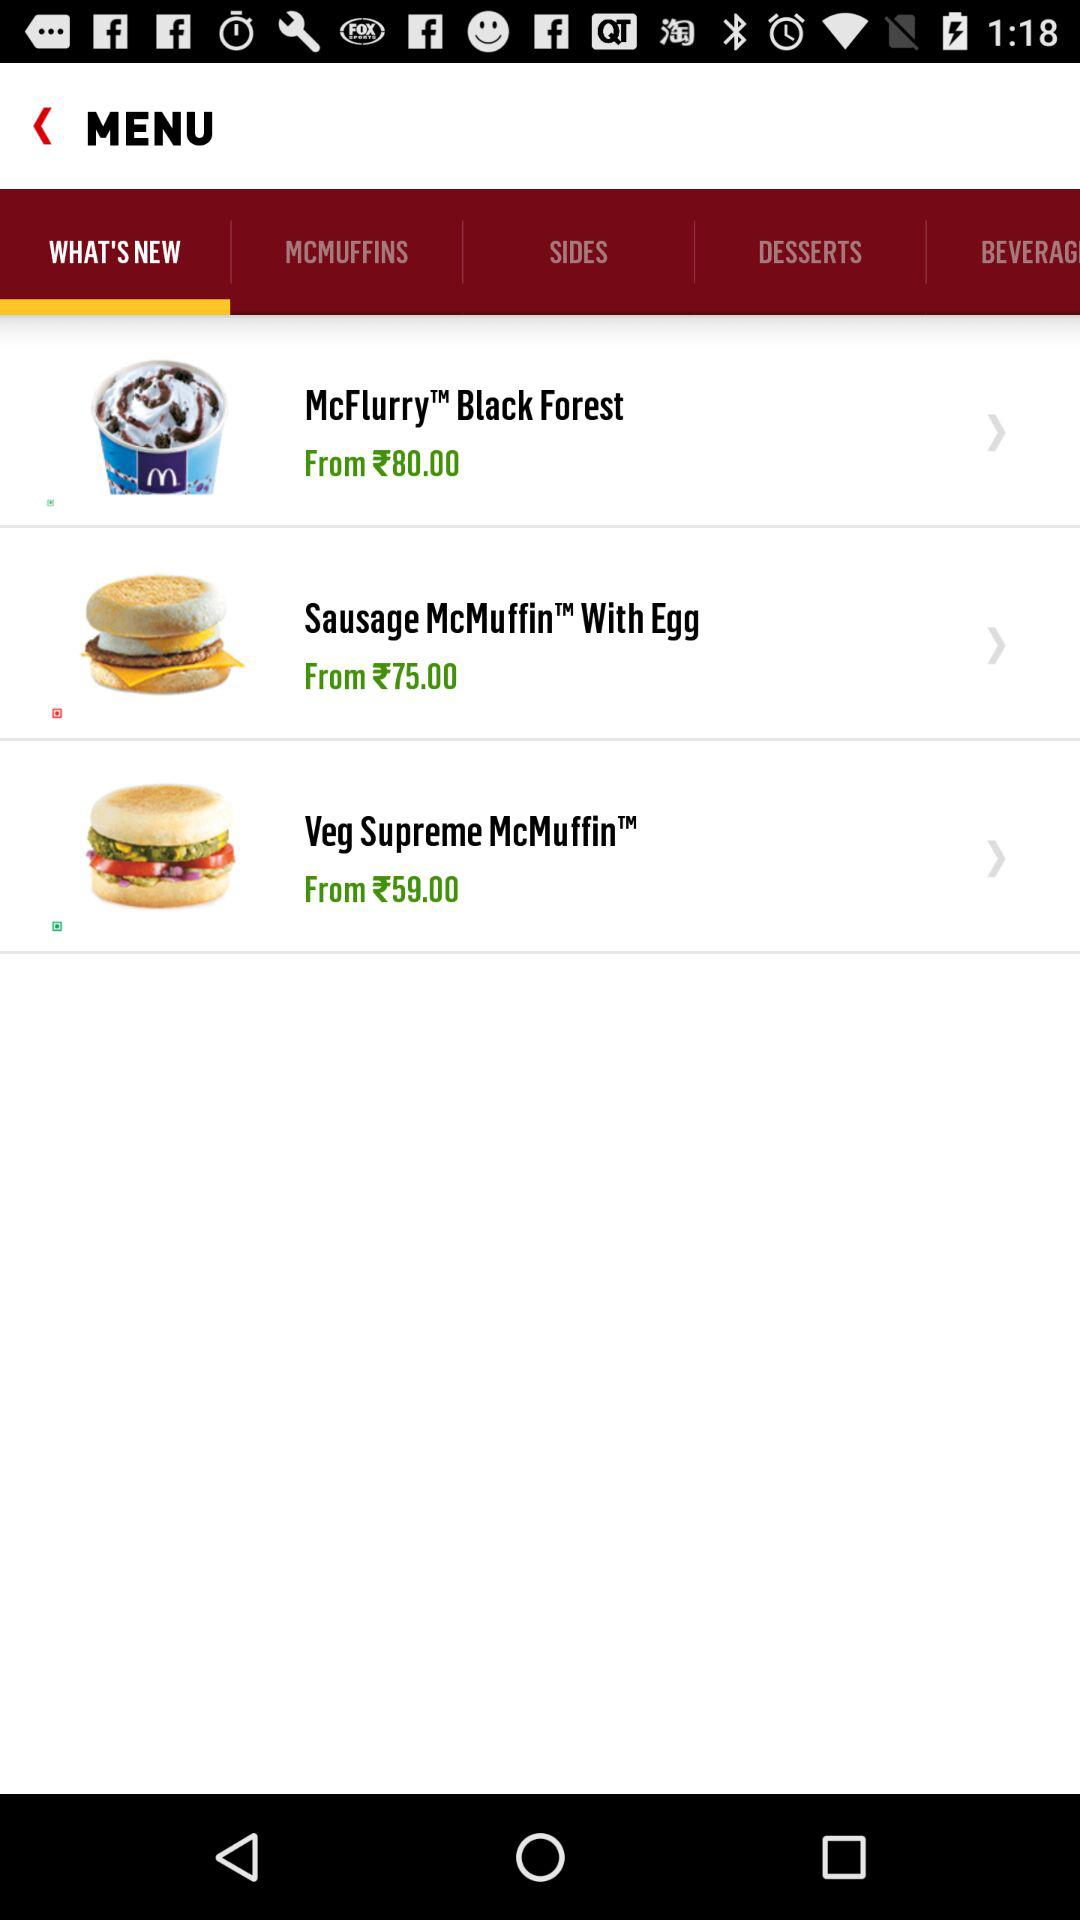What is the price of the "Veg Supreme McMuffin"? The price starts at 59 rupees. 